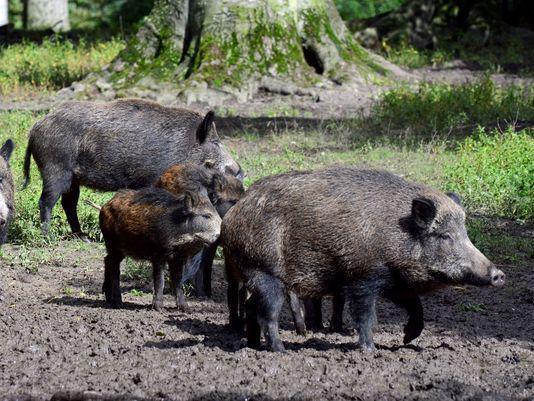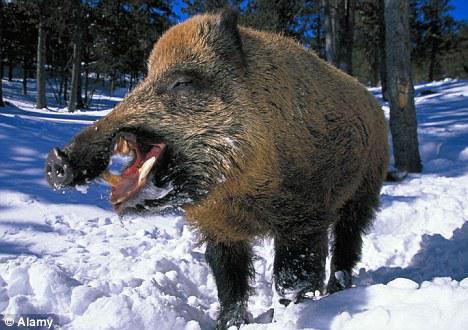The first image is the image on the left, the second image is the image on the right. Given the left and right images, does the statement "A single boar is facing the camera" hold true? Answer yes or no. No. 